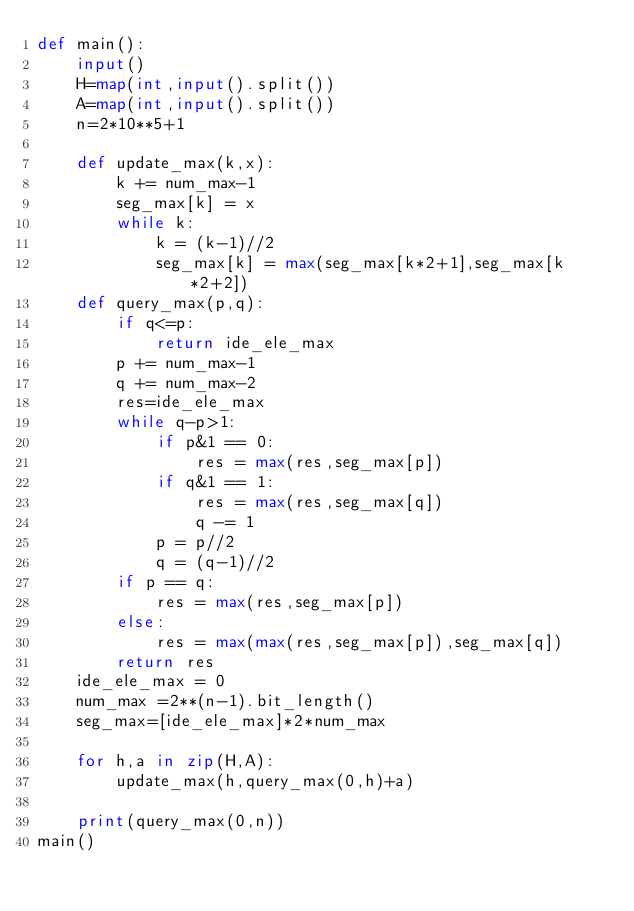<code> <loc_0><loc_0><loc_500><loc_500><_Python_>def main():
    input()
    H=map(int,input().split())
    A=map(int,input().split())
    n=2*10**5+1

    def update_max(k,x):
        k += num_max-1
        seg_max[k] = x
        while k:
            k = (k-1)//2
            seg_max[k] = max(seg_max[k*2+1],seg_max[k*2+2])
    def query_max(p,q):
        if q<=p:
            return ide_ele_max
        p += num_max-1
        q += num_max-2
        res=ide_ele_max
        while q-p>1:
            if p&1 == 0:
                res = max(res,seg_max[p])
            if q&1 == 1:
                res = max(res,seg_max[q])
                q -= 1
            p = p//2
            q = (q-1)//2
        if p == q:
            res = max(res,seg_max[p])
        else:
            res = max(max(res,seg_max[p]),seg_max[q])
        return res
    ide_ele_max = 0
    num_max =2**(n-1).bit_length()
    seg_max=[ide_ele_max]*2*num_max

    for h,a in zip(H,A):
        update_max(h,query_max(0,h)+a)
    
    print(query_max(0,n))
main()</code> 